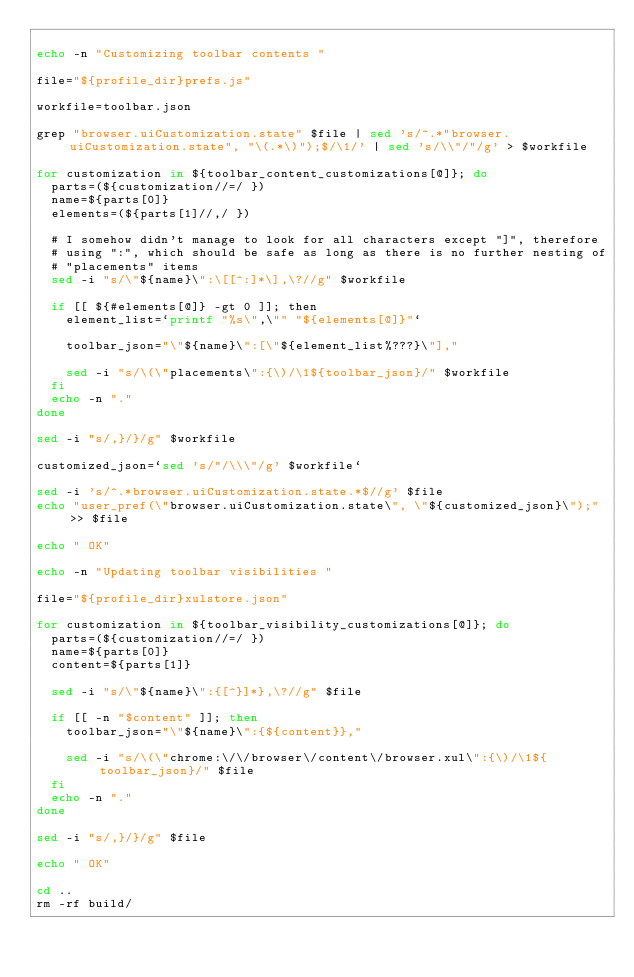Convert code to text. <code><loc_0><loc_0><loc_500><loc_500><_Bash_>
echo -n "Customizing toolbar contents "

file="${profile_dir}prefs.js"

workfile=toolbar.json

grep "browser.uiCustomization.state" $file | sed 's/^.*"browser.uiCustomization.state", "\(.*\)");$/\1/' | sed 's/\\"/"/g' > $workfile

for customization in ${toolbar_content_customizations[@]}; do
  parts=(${customization//=/ })
  name=${parts[0]}
  elements=(${parts[1]//,/ })

  # I somehow didn't manage to look for all characters except "]", therefore
  # using ":", which should be safe as long as there is no further nesting of
  # "placements" items
  sed -i "s/\"${name}\":\[[^:]*\],\?//g" $workfile

  if [[ ${#elements[@]} -gt 0 ]]; then
    element_list=`printf "%s\",\"" "${elements[@]}"`

    toolbar_json="\"${name}\":[\"${element_list%???}\"],"

    sed -i "s/\(\"placements\":{\)/\1${toolbar_json}/" $workfile
  fi
  echo -n "."
done

sed -i "s/,}/}/g" $workfile

customized_json=`sed 's/"/\\\"/g' $workfile`

sed -i 's/^.*browser.uiCustomization.state.*$//g' $file
echo "user_pref(\"browser.uiCustomization.state\", \"${customized_json}\");" >> $file

echo " OK"

echo -n "Updating toolbar visibilities "

file="${profile_dir}xulstore.json"

for customization in ${toolbar_visibility_customizations[@]}; do
  parts=(${customization//=/ })
  name=${parts[0]}
  content=${parts[1]}

  sed -i "s/\"${name}\":{[^}]*},\?//g" $file

  if [[ -n "$content" ]]; then
    toolbar_json="\"${name}\":{${content}},"

    sed -i "s/\(\"chrome:\/\/browser\/content\/browser.xul\":{\)/\1${toolbar_json}/" $file
  fi
  echo -n "."
done

sed -i "s/,}/}/g" $file

echo " OK"

cd ..
rm -rf build/
</code> 